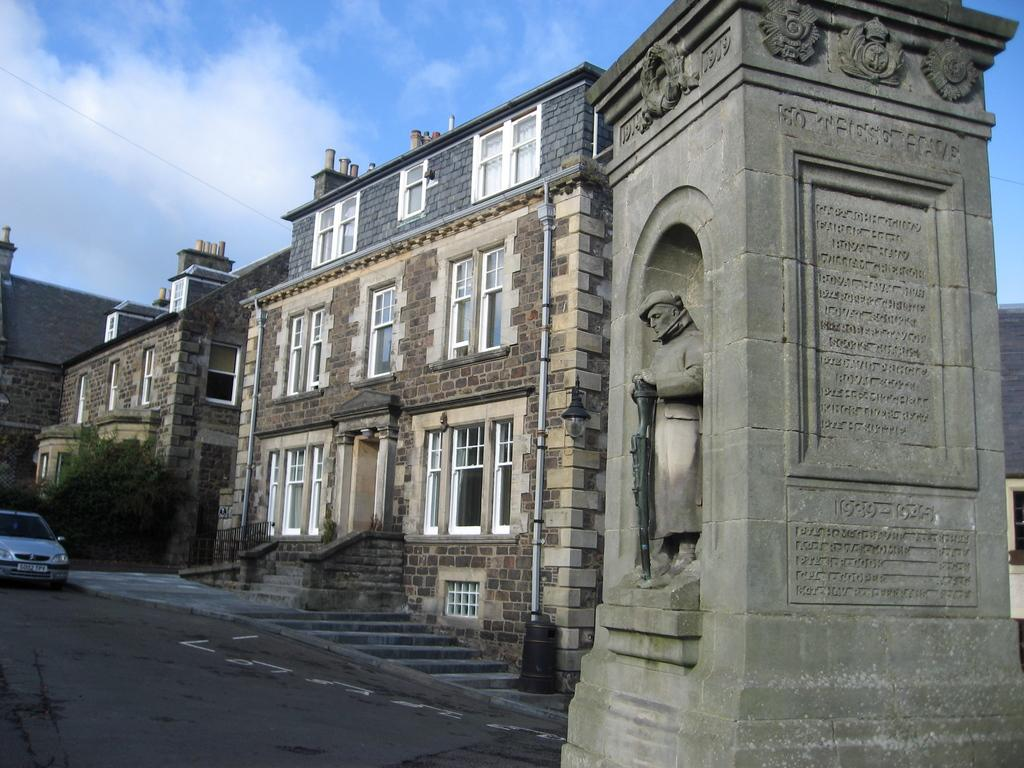What is the main subject of the image? There is a stone pillar with a statue in the image. What can be seen in the background of the image? There are stone buildings, cars, trees, and the sky visible in the background of the image. What is the condition of the sky in the image? The sky is visible in the background of the image, and clouds are present. What type of tank can be seen in the image? There is no tank present in the image. What kind of vessel is the statue holding in the image? The statue is not holding any vessel in the image. 